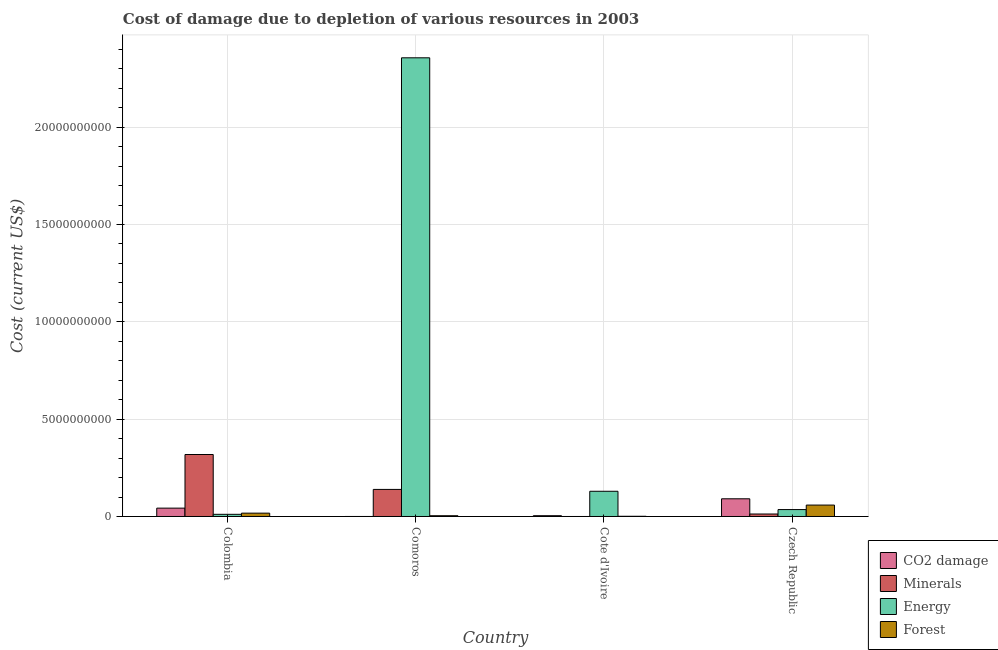How many different coloured bars are there?
Keep it short and to the point. 4. Are the number of bars per tick equal to the number of legend labels?
Offer a very short reply. Yes. What is the cost of damage due to depletion of energy in Czech Republic?
Make the answer very short. 3.55e+08. Across all countries, what is the maximum cost of damage due to depletion of forests?
Ensure brevity in your answer.  5.86e+08. Across all countries, what is the minimum cost of damage due to depletion of coal?
Give a very brief answer. 7.40e+05. In which country was the cost of damage due to depletion of energy maximum?
Offer a very short reply. Comoros. In which country was the cost of damage due to depletion of coal minimum?
Ensure brevity in your answer.  Comoros. What is the total cost of damage due to depletion of energy in the graph?
Offer a very short reply. 2.53e+1. What is the difference between the cost of damage due to depletion of forests in Colombia and that in Czech Republic?
Your answer should be very brief. -4.15e+08. What is the difference between the cost of damage due to depletion of forests in Cote d'Ivoire and the cost of damage due to depletion of minerals in Czech Republic?
Make the answer very short. -1.17e+08. What is the average cost of damage due to depletion of coal per country?
Provide a short and direct response. 3.45e+08. What is the difference between the cost of damage due to depletion of minerals and cost of damage due to depletion of forests in Colombia?
Offer a very short reply. 3.01e+09. What is the ratio of the cost of damage due to depletion of energy in Colombia to that in Comoros?
Your answer should be compact. 0. Is the cost of damage due to depletion of coal in Comoros less than that in Czech Republic?
Your answer should be compact. Yes. Is the difference between the cost of damage due to depletion of minerals in Cote d'Ivoire and Czech Republic greater than the difference between the cost of damage due to depletion of forests in Cote d'Ivoire and Czech Republic?
Give a very brief answer. Yes. What is the difference between the highest and the second highest cost of damage due to depletion of minerals?
Offer a very short reply. 1.79e+09. What is the difference between the highest and the lowest cost of damage due to depletion of minerals?
Your answer should be compact. 3.18e+09. Is the sum of the cost of damage due to depletion of forests in Colombia and Cote d'Ivoire greater than the maximum cost of damage due to depletion of energy across all countries?
Ensure brevity in your answer.  No. Is it the case that in every country, the sum of the cost of damage due to depletion of coal and cost of damage due to depletion of energy is greater than the sum of cost of damage due to depletion of forests and cost of damage due to depletion of minerals?
Make the answer very short. No. What does the 2nd bar from the left in Colombia represents?
Give a very brief answer. Minerals. What does the 1st bar from the right in Comoros represents?
Make the answer very short. Forest. Is it the case that in every country, the sum of the cost of damage due to depletion of coal and cost of damage due to depletion of minerals is greater than the cost of damage due to depletion of energy?
Offer a very short reply. No. How many bars are there?
Make the answer very short. 16. How many countries are there in the graph?
Provide a succinct answer. 4. What is the difference between two consecutive major ticks on the Y-axis?
Your response must be concise. 5.00e+09. Are the values on the major ticks of Y-axis written in scientific E-notation?
Make the answer very short. No. How many legend labels are there?
Your answer should be compact. 4. How are the legend labels stacked?
Your answer should be very brief. Vertical. What is the title of the graph?
Your answer should be compact. Cost of damage due to depletion of various resources in 2003 . What is the label or title of the X-axis?
Offer a terse response. Country. What is the label or title of the Y-axis?
Keep it short and to the point. Cost (current US$). What is the Cost (current US$) in CO2 damage in Colombia?
Your response must be concise. 4.29e+08. What is the Cost (current US$) of Minerals in Colombia?
Your answer should be very brief. 3.18e+09. What is the Cost (current US$) in Energy in Colombia?
Make the answer very short. 1.11e+08. What is the Cost (current US$) in Forest in Colombia?
Make the answer very short. 1.71e+08. What is the Cost (current US$) in CO2 damage in Comoros?
Offer a terse response. 7.40e+05. What is the Cost (current US$) of Minerals in Comoros?
Your answer should be compact. 1.39e+09. What is the Cost (current US$) in Energy in Comoros?
Your answer should be very brief. 2.36e+1. What is the Cost (current US$) of Forest in Comoros?
Offer a terse response. 3.91e+07. What is the Cost (current US$) in CO2 damage in Cote d'Ivoire?
Your response must be concise. 4.08e+07. What is the Cost (current US$) in Minerals in Cote d'Ivoire?
Your response must be concise. 1.34e+04. What is the Cost (current US$) of Energy in Cote d'Ivoire?
Give a very brief answer. 1.30e+09. What is the Cost (current US$) of Forest in Cote d'Ivoire?
Offer a very short reply. 1.06e+07. What is the Cost (current US$) in CO2 damage in Czech Republic?
Your answer should be compact. 9.09e+08. What is the Cost (current US$) in Minerals in Czech Republic?
Keep it short and to the point. 1.28e+08. What is the Cost (current US$) of Energy in Czech Republic?
Give a very brief answer. 3.55e+08. What is the Cost (current US$) in Forest in Czech Republic?
Your answer should be very brief. 5.86e+08. Across all countries, what is the maximum Cost (current US$) of CO2 damage?
Provide a succinct answer. 9.09e+08. Across all countries, what is the maximum Cost (current US$) of Minerals?
Provide a succinct answer. 3.18e+09. Across all countries, what is the maximum Cost (current US$) in Energy?
Your response must be concise. 2.36e+1. Across all countries, what is the maximum Cost (current US$) of Forest?
Give a very brief answer. 5.86e+08. Across all countries, what is the minimum Cost (current US$) of CO2 damage?
Your answer should be very brief. 7.40e+05. Across all countries, what is the minimum Cost (current US$) of Minerals?
Give a very brief answer. 1.34e+04. Across all countries, what is the minimum Cost (current US$) of Energy?
Offer a terse response. 1.11e+08. Across all countries, what is the minimum Cost (current US$) of Forest?
Make the answer very short. 1.06e+07. What is the total Cost (current US$) of CO2 damage in the graph?
Keep it short and to the point. 1.38e+09. What is the total Cost (current US$) in Minerals in the graph?
Make the answer very short. 4.70e+09. What is the total Cost (current US$) in Energy in the graph?
Your answer should be very brief. 2.53e+1. What is the total Cost (current US$) of Forest in the graph?
Provide a short and direct response. 8.07e+08. What is the difference between the Cost (current US$) in CO2 damage in Colombia and that in Comoros?
Keep it short and to the point. 4.28e+08. What is the difference between the Cost (current US$) of Minerals in Colombia and that in Comoros?
Offer a terse response. 1.79e+09. What is the difference between the Cost (current US$) in Energy in Colombia and that in Comoros?
Give a very brief answer. -2.35e+1. What is the difference between the Cost (current US$) in Forest in Colombia and that in Comoros?
Your answer should be compact. 1.32e+08. What is the difference between the Cost (current US$) in CO2 damage in Colombia and that in Cote d'Ivoire?
Make the answer very short. 3.88e+08. What is the difference between the Cost (current US$) in Minerals in Colombia and that in Cote d'Ivoire?
Your response must be concise. 3.18e+09. What is the difference between the Cost (current US$) of Energy in Colombia and that in Cote d'Ivoire?
Your response must be concise. -1.18e+09. What is the difference between the Cost (current US$) in Forest in Colombia and that in Cote d'Ivoire?
Provide a short and direct response. 1.61e+08. What is the difference between the Cost (current US$) in CO2 damage in Colombia and that in Czech Republic?
Keep it short and to the point. -4.80e+08. What is the difference between the Cost (current US$) of Minerals in Colombia and that in Czech Republic?
Ensure brevity in your answer.  3.06e+09. What is the difference between the Cost (current US$) in Energy in Colombia and that in Czech Republic?
Give a very brief answer. -2.44e+08. What is the difference between the Cost (current US$) of Forest in Colombia and that in Czech Republic?
Give a very brief answer. -4.15e+08. What is the difference between the Cost (current US$) in CO2 damage in Comoros and that in Cote d'Ivoire?
Offer a terse response. -4.01e+07. What is the difference between the Cost (current US$) of Minerals in Comoros and that in Cote d'Ivoire?
Provide a short and direct response. 1.39e+09. What is the difference between the Cost (current US$) of Energy in Comoros and that in Cote d'Ivoire?
Your answer should be compact. 2.23e+1. What is the difference between the Cost (current US$) of Forest in Comoros and that in Cote d'Ivoire?
Offer a terse response. 2.85e+07. What is the difference between the Cost (current US$) in CO2 damage in Comoros and that in Czech Republic?
Your answer should be compact. -9.09e+08. What is the difference between the Cost (current US$) of Minerals in Comoros and that in Czech Republic?
Ensure brevity in your answer.  1.26e+09. What is the difference between the Cost (current US$) of Energy in Comoros and that in Czech Republic?
Offer a very short reply. 2.32e+1. What is the difference between the Cost (current US$) in Forest in Comoros and that in Czech Republic?
Your answer should be very brief. -5.47e+08. What is the difference between the Cost (current US$) of CO2 damage in Cote d'Ivoire and that in Czech Republic?
Ensure brevity in your answer.  -8.68e+08. What is the difference between the Cost (current US$) in Minerals in Cote d'Ivoire and that in Czech Republic?
Your answer should be very brief. -1.28e+08. What is the difference between the Cost (current US$) of Energy in Cote d'Ivoire and that in Czech Republic?
Provide a short and direct response. 9.40e+08. What is the difference between the Cost (current US$) of Forest in Cote d'Ivoire and that in Czech Republic?
Provide a succinct answer. -5.76e+08. What is the difference between the Cost (current US$) in CO2 damage in Colombia and the Cost (current US$) in Minerals in Comoros?
Provide a succinct answer. -9.62e+08. What is the difference between the Cost (current US$) in CO2 damage in Colombia and the Cost (current US$) in Energy in Comoros?
Make the answer very short. -2.31e+1. What is the difference between the Cost (current US$) in CO2 damage in Colombia and the Cost (current US$) in Forest in Comoros?
Make the answer very short. 3.90e+08. What is the difference between the Cost (current US$) of Minerals in Colombia and the Cost (current US$) of Energy in Comoros?
Your answer should be compact. -2.04e+1. What is the difference between the Cost (current US$) of Minerals in Colombia and the Cost (current US$) of Forest in Comoros?
Your answer should be compact. 3.14e+09. What is the difference between the Cost (current US$) in Energy in Colombia and the Cost (current US$) in Forest in Comoros?
Offer a terse response. 7.19e+07. What is the difference between the Cost (current US$) in CO2 damage in Colombia and the Cost (current US$) in Minerals in Cote d'Ivoire?
Your answer should be compact. 4.29e+08. What is the difference between the Cost (current US$) of CO2 damage in Colombia and the Cost (current US$) of Energy in Cote d'Ivoire?
Offer a very short reply. -8.66e+08. What is the difference between the Cost (current US$) of CO2 damage in Colombia and the Cost (current US$) of Forest in Cote d'Ivoire?
Provide a succinct answer. 4.18e+08. What is the difference between the Cost (current US$) in Minerals in Colombia and the Cost (current US$) in Energy in Cote d'Ivoire?
Your answer should be compact. 1.89e+09. What is the difference between the Cost (current US$) of Minerals in Colombia and the Cost (current US$) of Forest in Cote d'Ivoire?
Keep it short and to the point. 3.17e+09. What is the difference between the Cost (current US$) of Energy in Colombia and the Cost (current US$) of Forest in Cote d'Ivoire?
Your response must be concise. 1.00e+08. What is the difference between the Cost (current US$) in CO2 damage in Colombia and the Cost (current US$) in Minerals in Czech Republic?
Your answer should be compact. 3.01e+08. What is the difference between the Cost (current US$) of CO2 damage in Colombia and the Cost (current US$) of Energy in Czech Republic?
Give a very brief answer. 7.40e+07. What is the difference between the Cost (current US$) in CO2 damage in Colombia and the Cost (current US$) in Forest in Czech Republic?
Offer a terse response. -1.57e+08. What is the difference between the Cost (current US$) of Minerals in Colombia and the Cost (current US$) of Energy in Czech Republic?
Make the answer very short. 2.83e+09. What is the difference between the Cost (current US$) of Minerals in Colombia and the Cost (current US$) of Forest in Czech Republic?
Make the answer very short. 2.60e+09. What is the difference between the Cost (current US$) of Energy in Colombia and the Cost (current US$) of Forest in Czech Republic?
Keep it short and to the point. -4.75e+08. What is the difference between the Cost (current US$) of CO2 damage in Comoros and the Cost (current US$) of Minerals in Cote d'Ivoire?
Your answer should be compact. 7.26e+05. What is the difference between the Cost (current US$) of CO2 damage in Comoros and the Cost (current US$) of Energy in Cote d'Ivoire?
Offer a very short reply. -1.29e+09. What is the difference between the Cost (current US$) of CO2 damage in Comoros and the Cost (current US$) of Forest in Cote d'Ivoire?
Your response must be concise. -9.88e+06. What is the difference between the Cost (current US$) of Minerals in Comoros and the Cost (current US$) of Energy in Cote d'Ivoire?
Offer a very short reply. 9.56e+07. What is the difference between the Cost (current US$) in Minerals in Comoros and the Cost (current US$) in Forest in Cote d'Ivoire?
Ensure brevity in your answer.  1.38e+09. What is the difference between the Cost (current US$) of Energy in Comoros and the Cost (current US$) of Forest in Cote d'Ivoire?
Your response must be concise. 2.36e+1. What is the difference between the Cost (current US$) of CO2 damage in Comoros and the Cost (current US$) of Minerals in Czech Republic?
Provide a succinct answer. -1.27e+08. What is the difference between the Cost (current US$) of CO2 damage in Comoros and the Cost (current US$) of Energy in Czech Republic?
Provide a succinct answer. -3.54e+08. What is the difference between the Cost (current US$) in CO2 damage in Comoros and the Cost (current US$) in Forest in Czech Republic?
Offer a terse response. -5.85e+08. What is the difference between the Cost (current US$) in Minerals in Comoros and the Cost (current US$) in Energy in Czech Republic?
Your answer should be compact. 1.04e+09. What is the difference between the Cost (current US$) of Minerals in Comoros and the Cost (current US$) of Forest in Czech Republic?
Make the answer very short. 8.04e+08. What is the difference between the Cost (current US$) in Energy in Comoros and the Cost (current US$) in Forest in Czech Republic?
Your response must be concise. 2.30e+1. What is the difference between the Cost (current US$) in CO2 damage in Cote d'Ivoire and the Cost (current US$) in Minerals in Czech Republic?
Give a very brief answer. -8.68e+07. What is the difference between the Cost (current US$) in CO2 damage in Cote d'Ivoire and the Cost (current US$) in Energy in Czech Republic?
Your response must be concise. -3.14e+08. What is the difference between the Cost (current US$) of CO2 damage in Cote d'Ivoire and the Cost (current US$) of Forest in Czech Republic?
Ensure brevity in your answer.  -5.45e+08. What is the difference between the Cost (current US$) in Minerals in Cote d'Ivoire and the Cost (current US$) in Energy in Czech Republic?
Offer a very short reply. -3.55e+08. What is the difference between the Cost (current US$) of Minerals in Cote d'Ivoire and the Cost (current US$) of Forest in Czech Republic?
Your response must be concise. -5.86e+08. What is the difference between the Cost (current US$) in Energy in Cote d'Ivoire and the Cost (current US$) in Forest in Czech Republic?
Give a very brief answer. 7.09e+08. What is the average Cost (current US$) of CO2 damage per country?
Make the answer very short. 3.45e+08. What is the average Cost (current US$) in Minerals per country?
Make the answer very short. 1.18e+09. What is the average Cost (current US$) of Energy per country?
Provide a short and direct response. 6.33e+09. What is the average Cost (current US$) of Forest per country?
Ensure brevity in your answer.  2.02e+08. What is the difference between the Cost (current US$) of CO2 damage and Cost (current US$) of Minerals in Colombia?
Provide a short and direct response. -2.75e+09. What is the difference between the Cost (current US$) in CO2 damage and Cost (current US$) in Energy in Colombia?
Offer a terse response. 3.18e+08. What is the difference between the Cost (current US$) in CO2 damage and Cost (current US$) in Forest in Colombia?
Your answer should be very brief. 2.58e+08. What is the difference between the Cost (current US$) in Minerals and Cost (current US$) in Energy in Colombia?
Your answer should be very brief. 3.07e+09. What is the difference between the Cost (current US$) in Minerals and Cost (current US$) in Forest in Colombia?
Keep it short and to the point. 3.01e+09. What is the difference between the Cost (current US$) of Energy and Cost (current US$) of Forest in Colombia?
Give a very brief answer. -6.05e+07. What is the difference between the Cost (current US$) in CO2 damage and Cost (current US$) in Minerals in Comoros?
Provide a succinct answer. -1.39e+09. What is the difference between the Cost (current US$) of CO2 damage and Cost (current US$) of Energy in Comoros?
Provide a succinct answer. -2.36e+1. What is the difference between the Cost (current US$) in CO2 damage and Cost (current US$) in Forest in Comoros?
Provide a short and direct response. -3.83e+07. What is the difference between the Cost (current US$) of Minerals and Cost (current US$) of Energy in Comoros?
Your response must be concise. -2.22e+1. What is the difference between the Cost (current US$) of Minerals and Cost (current US$) of Forest in Comoros?
Provide a short and direct response. 1.35e+09. What is the difference between the Cost (current US$) of Energy and Cost (current US$) of Forest in Comoros?
Ensure brevity in your answer.  2.35e+1. What is the difference between the Cost (current US$) of CO2 damage and Cost (current US$) of Minerals in Cote d'Ivoire?
Offer a very short reply. 4.08e+07. What is the difference between the Cost (current US$) of CO2 damage and Cost (current US$) of Energy in Cote d'Ivoire?
Provide a short and direct response. -1.25e+09. What is the difference between the Cost (current US$) of CO2 damage and Cost (current US$) of Forest in Cote d'Ivoire?
Your answer should be very brief. 3.02e+07. What is the difference between the Cost (current US$) in Minerals and Cost (current US$) in Energy in Cote d'Ivoire?
Your response must be concise. -1.30e+09. What is the difference between the Cost (current US$) of Minerals and Cost (current US$) of Forest in Cote d'Ivoire?
Ensure brevity in your answer.  -1.06e+07. What is the difference between the Cost (current US$) of Energy and Cost (current US$) of Forest in Cote d'Ivoire?
Offer a very short reply. 1.28e+09. What is the difference between the Cost (current US$) in CO2 damage and Cost (current US$) in Minerals in Czech Republic?
Offer a terse response. 7.82e+08. What is the difference between the Cost (current US$) of CO2 damage and Cost (current US$) of Energy in Czech Republic?
Your answer should be compact. 5.54e+08. What is the difference between the Cost (current US$) of CO2 damage and Cost (current US$) of Forest in Czech Republic?
Your answer should be very brief. 3.23e+08. What is the difference between the Cost (current US$) in Minerals and Cost (current US$) in Energy in Czech Republic?
Keep it short and to the point. -2.27e+08. What is the difference between the Cost (current US$) in Minerals and Cost (current US$) in Forest in Czech Republic?
Provide a short and direct response. -4.59e+08. What is the difference between the Cost (current US$) of Energy and Cost (current US$) of Forest in Czech Republic?
Your answer should be compact. -2.31e+08. What is the ratio of the Cost (current US$) of CO2 damage in Colombia to that in Comoros?
Make the answer very short. 579.96. What is the ratio of the Cost (current US$) in Minerals in Colombia to that in Comoros?
Offer a terse response. 2.29. What is the ratio of the Cost (current US$) of Energy in Colombia to that in Comoros?
Offer a terse response. 0. What is the ratio of the Cost (current US$) in Forest in Colombia to that in Comoros?
Keep it short and to the point. 4.39. What is the ratio of the Cost (current US$) of CO2 damage in Colombia to that in Cote d'Ivoire?
Your response must be concise. 10.52. What is the ratio of the Cost (current US$) of Minerals in Colombia to that in Cote d'Ivoire?
Provide a succinct answer. 2.37e+05. What is the ratio of the Cost (current US$) in Energy in Colombia to that in Cote d'Ivoire?
Give a very brief answer. 0.09. What is the ratio of the Cost (current US$) of Forest in Colombia to that in Cote d'Ivoire?
Keep it short and to the point. 16.15. What is the ratio of the Cost (current US$) of CO2 damage in Colombia to that in Czech Republic?
Give a very brief answer. 0.47. What is the ratio of the Cost (current US$) in Minerals in Colombia to that in Czech Republic?
Offer a terse response. 24.95. What is the ratio of the Cost (current US$) in Energy in Colombia to that in Czech Republic?
Give a very brief answer. 0.31. What is the ratio of the Cost (current US$) of Forest in Colombia to that in Czech Republic?
Give a very brief answer. 0.29. What is the ratio of the Cost (current US$) of CO2 damage in Comoros to that in Cote d'Ivoire?
Ensure brevity in your answer.  0.02. What is the ratio of the Cost (current US$) of Minerals in Comoros to that in Cote d'Ivoire?
Provide a short and direct response. 1.03e+05. What is the ratio of the Cost (current US$) in Energy in Comoros to that in Cote d'Ivoire?
Offer a very short reply. 18.19. What is the ratio of the Cost (current US$) of Forest in Comoros to that in Cote d'Ivoire?
Make the answer very short. 3.68. What is the ratio of the Cost (current US$) in CO2 damage in Comoros to that in Czech Republic?
Ensure brevity in your answer.  0. What is the ratio of the Cost (current US$) in Minerals in Comoros to that in Czech Republic?
Offer a terse response. 10.9. What is the ratio of the Cost (current US$) in Energy in Comoros to that in Czech Republic?
Give a very brief answer. 66.37. What is the ratio of the Cost (current US$) in Forest in Comoros to that in Czech Republic?
Keep it short and to the point. 0.07. What is the ratio of the Cost (current US$) of CO2 damage in Cote d'Ivoire to that in Czech Republic?
Keep it short and to the point. 0.04. What is the ratio of the Cost (current US$) in Energy in Cote d'Ivoire to that in Czech Republic?
Give a very brief answer. 3.65. What is the ratio of the Cost (current US$) in Forest in Cote d'Ivoire to that in Czech Republic?
Your response must be concise. 0.02. What is the difference between the highest and the second highest Cost (current US$) in CO2 damage?
Your answer should be very brief. 4.80e+08. What is the difference between the highest and the second highest Cost (current US$) of Minerals?
Your answer should be very brief. 1.79e+09. What is the difference between the highest and the second highest Cost (current US$) in Energy?
Your response must be concise. 2.23e+1. What is the difference between the highest and the second highest Cost (current US$) in Forest?
Your response must be concise. 4.15e+08. What is the difference between the highest and the lowest Cost (current US$) in CO2 damage?
Your response must be concise. 9.09e+08. What is the difference between the highest and the lowest Cost (current US$) in Minerals?
Ensure brevity in your answer.  3.18e+09. What is the difference between the highest and the lowest Cost (current US$) in Energy?
Your answer should be compact. 2.35e+1. What is the difference between the highest and the lowest Cost (current US$) of Forest?
Ensure brevity in your answer.  5.76e+08. 